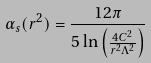<formula> <loc_0><loc_0><loc_500><loc_500>\alpha _ { s } ( r ^ { 2 } ) = \frac { 1 2 \pi } { 5 \ln \left ( \frac { 4 C ^ { 2 } } { r ^ { 2 } \Lambda ^ { 2 } } \right ) }</formula> 